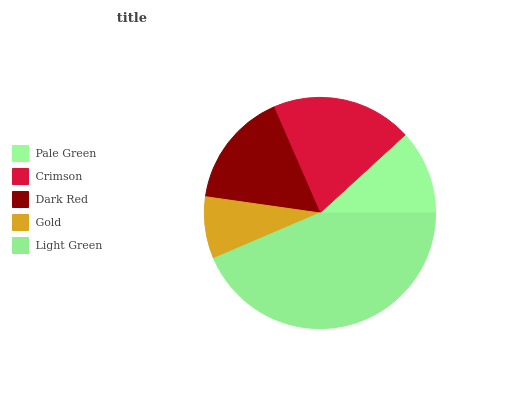Is Gold the minimum?
Answer yes or no. Yes. Is Light Green the maximum?
Answer yes or no. Yes. Is Crimson the minimum?
Answer yes or no. No. Is Crimson the maximum?
Answer yes or no. No. Is Crimson greater than Pale Green?
Answer yes or no. Yes. Is Pale Green less than Crimson?
Answer yes or no. Yes. Is Pale Green greater than Crimson?
Answer yes or no. No. Is Crimson less than Pale Green?
Answer yes or no. No. Is Dark Red the high median?
Answer yes or no. Yes. Is Dark Red the low median?
Answer yes or no. Yes. Is Crimson the high median?
Answer yes or no. No. Is Gold the low median?
Answer yes or no. No. 